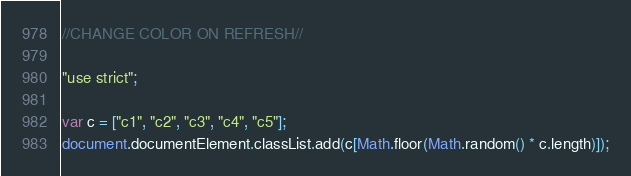Convert code to text. <code><loc_0><loc_0><loc_500><loc_500><_JavaScript_>//CHANGE COLOR ON REFRESH//

"use strict";

var c = ["c1", "c2", "c3", "c4", "c5"];
document.documentElement.classList.add(c[Math.floor(Math.random() * c.length)]);






</code> 